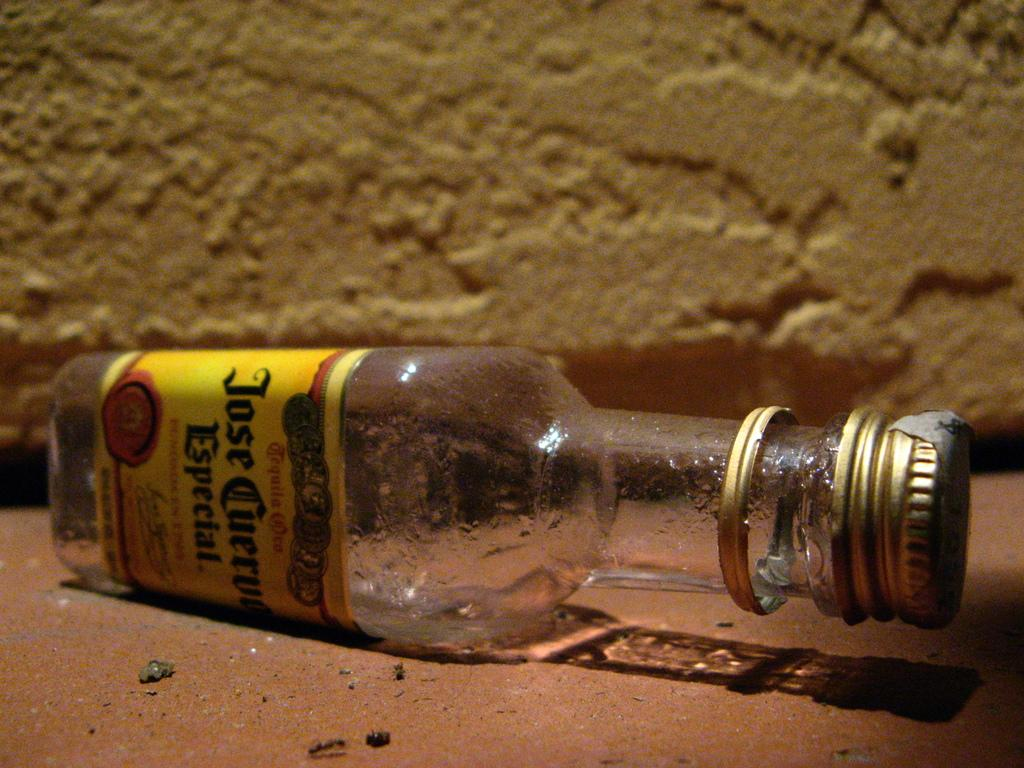<image>
Give a short and clear explanation of the subsequent image. An empty bottle of Jose Cuervo Especial lays on its side 